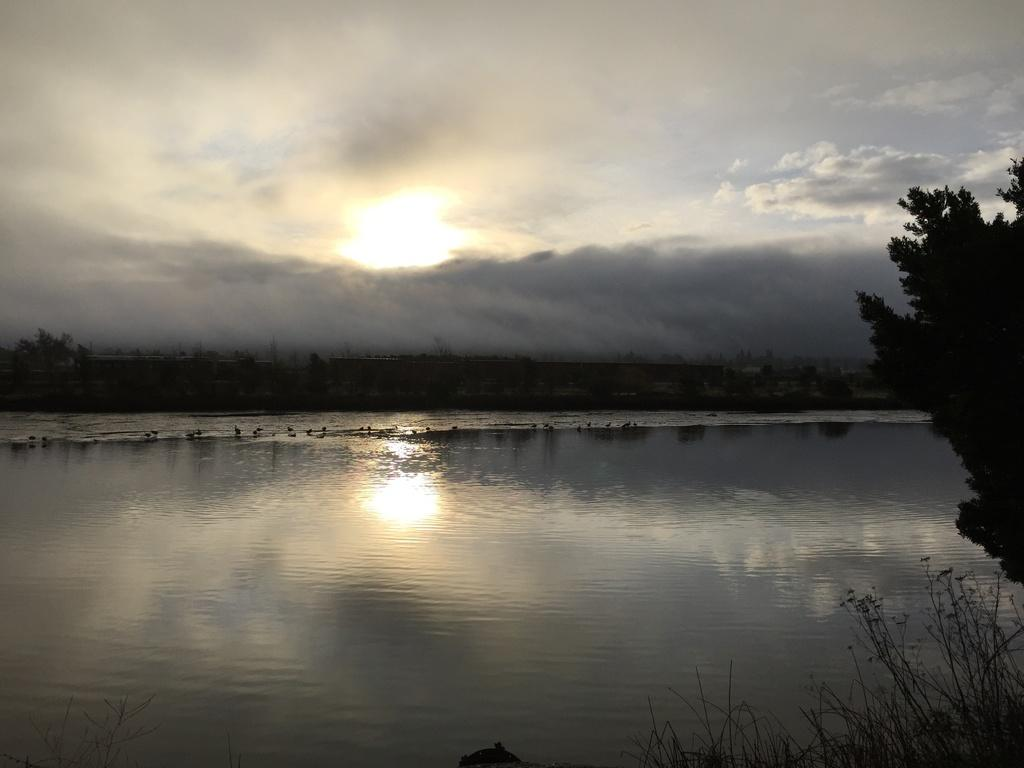What type of body of water is present in the image? There is a lake with water in the image. What other natural elements can be seen in the image? There is a group of trees in the image. What is visible in the sky in the image? The sky is visible in the image, and the sun and clouds are present. How many icicles are hanging from the trees in the image? There are no icicles present in the image, as it is not a winter scene. 